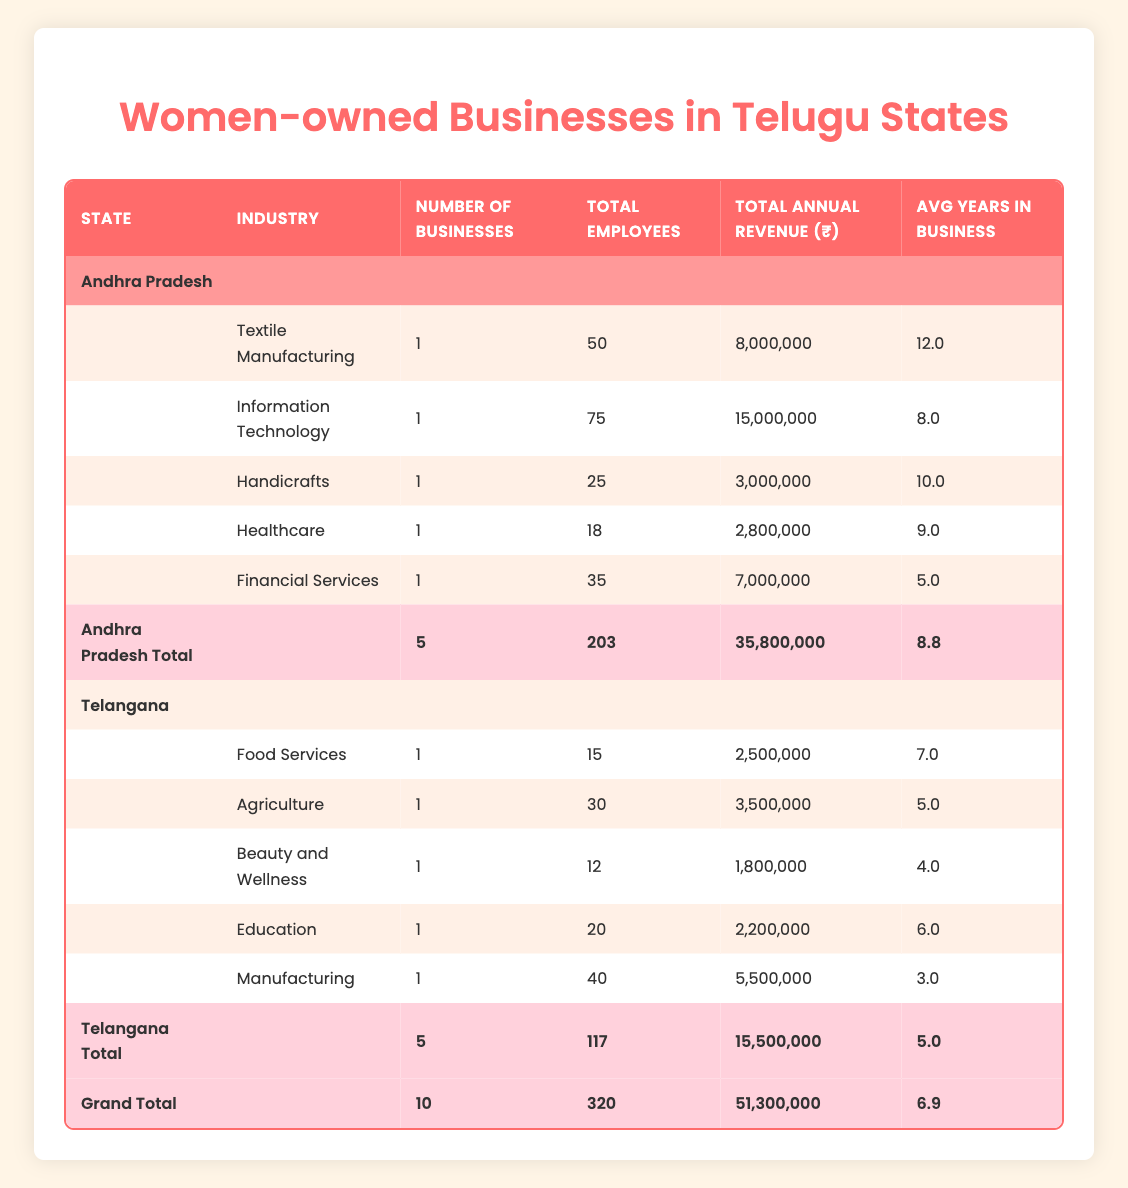What is the total number of businesses in Telangana? From the table's total row for Telangana, it indicates that there are 5 businesses at the total count.
Answer: 5 What is the average annual revenue for women-owned businesses in Andhra Pradesh? The total annual revenue for Andhra Pradesh is 35,800,000 and there are 5 businesses, so the average is calculated as 35,800,000 / 5 = 7,160,000.
Answer: 7,160,000 Is there a business in the healthcare industry owned by a woman in Andhra Pradesh? Checking the table shows that there is no entry under the healthcare industry for Andhra Pradesh, confirming that the statement is false.
Answer: No Which state has more total employees in women-owned businesses? Summing the total employees from both states: Andhra Pradesh has 203 employees, and Telangana has 117 employees. Since 203 is greater than 117, Andhra Pradesh has more employees.
Answer: Andhra Pradesh What is the difference in annual revenue between the highest grossing industry in Andhra Pradesh and Telangana? The highest revenue in Andhra Pradesh is from Information Technology at 15,000,000, while in Telangana, it is from Food Services at 2,500,000. The difference is 15,000,000 - 2,500,000 = 12,500,000.
Answer: 12,500,000 What percentage of total businesses is represented by the healthcare industry in Andhra Pradesh? There are 5 total businesses in Andhra Pradesh and 1 in healthcare, so the percentage is (1 / 5) * 100 = 20%.
Answer: 20% Which Tamil Nadu business earns the least amount of annual revenue? By looking through the annual revenue values, the lowest is from Glamour Beauty Salon in Telangana at 1,800,000.
Answer: 1,800,000 Is the average years in business for all women-owned businesses in Andhra Pradesh greater than 8? The average for Andhra Pradesh is calculated as 8.8, which is greater than 8, confirming the claim as true.
Answer: Yes Which industry in Telangana has the most total employees? Reviewing the employee counts shows the Manufacturing industry has 40 employees, the highest among the listed sectors in Telangana.
Answer: Manufacturing 